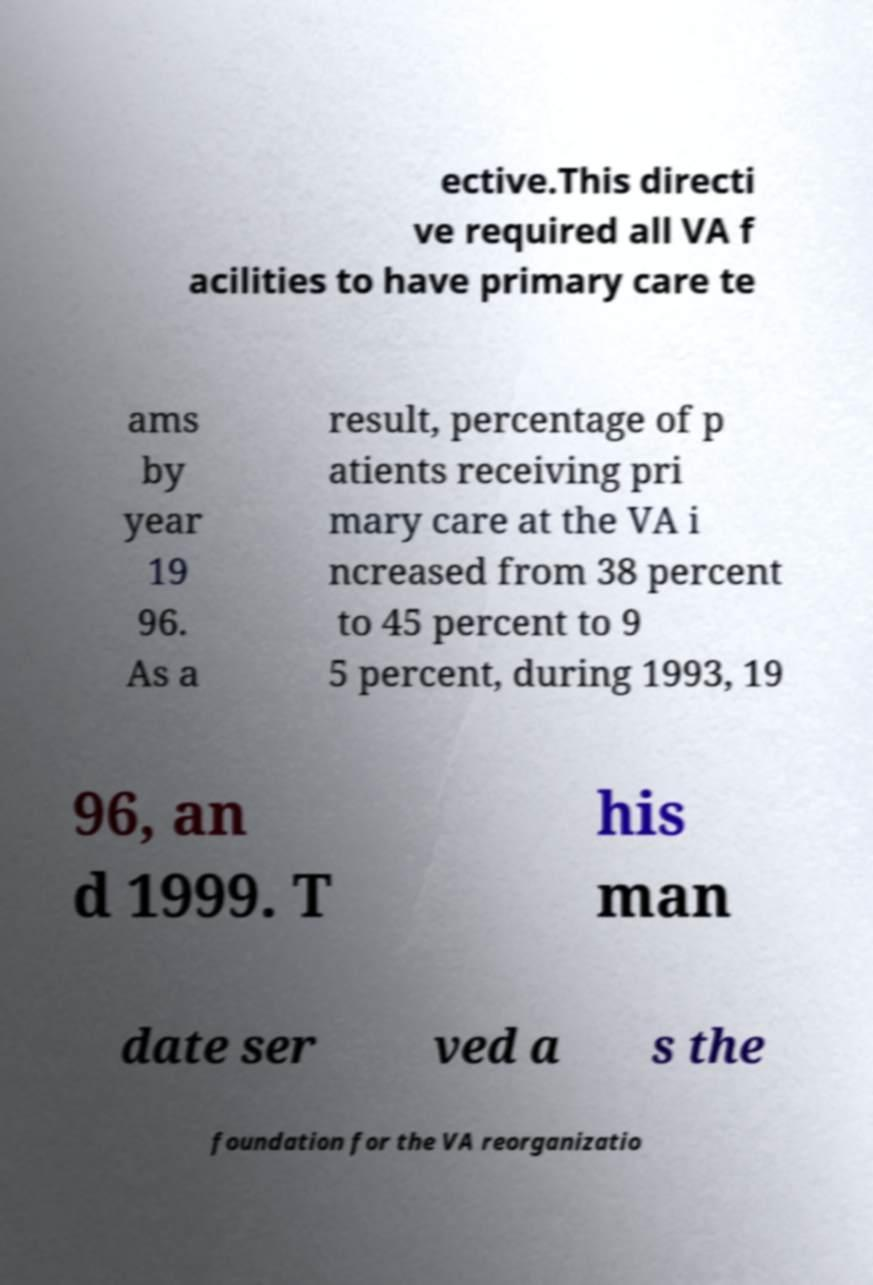For documentation purposes, I need the text within this image transcribed. Could you provide that? ective.This directi ve required all VA f acilities to have primary care te ams by year 19 96. As a result, percentage of p atients receiving pri mary care at the VA i ncreased from 38 percent to 45 percent to 9 5 percent, during 1993, 19 96, an d 1999. T his man date ser ved a s the foundation for the VA reorganizatio 